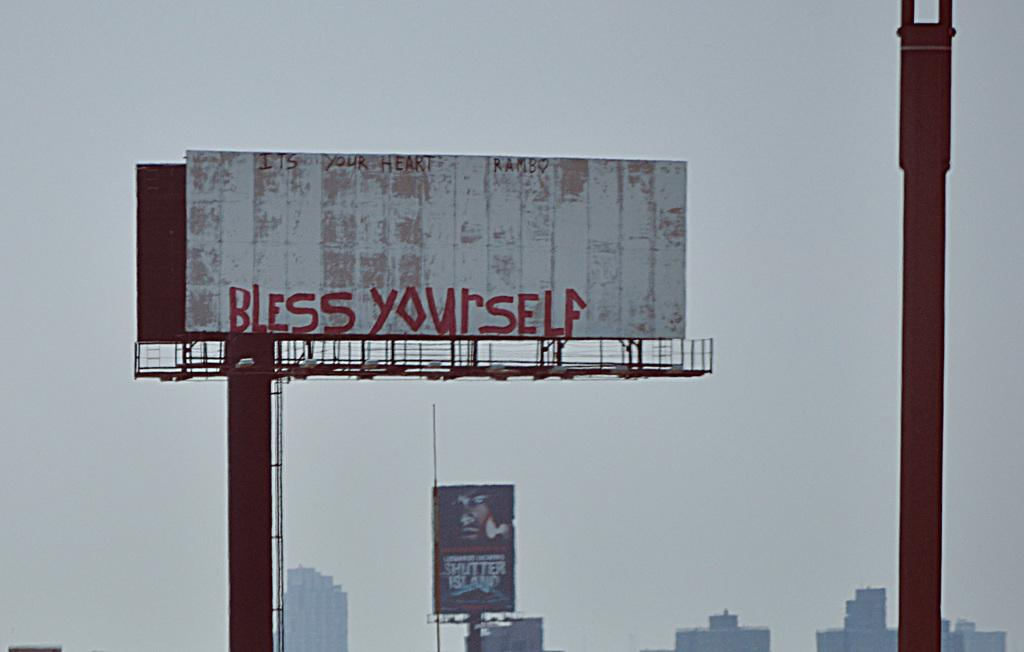<image>
Write a terse but informative summary of the picture. Bless yourself banner on top of a long pole 